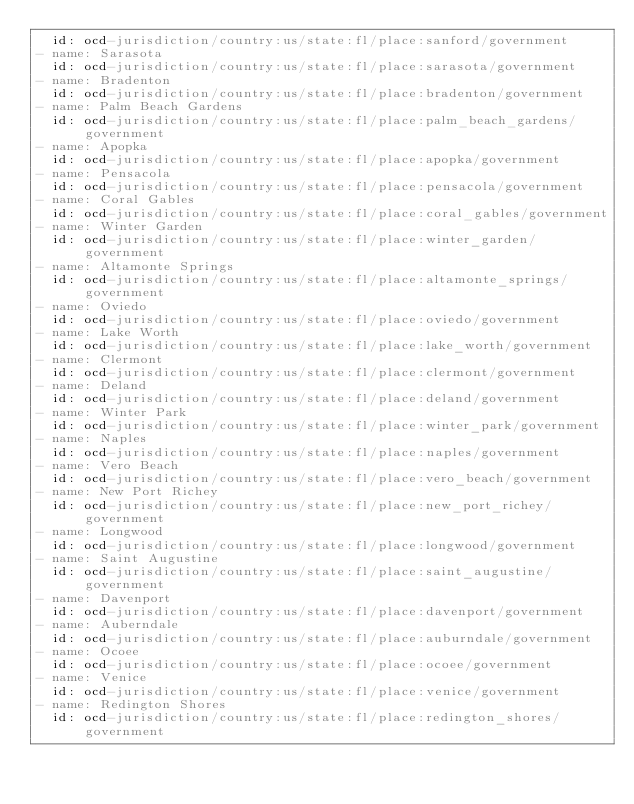<code> <loc_0><loc_0><loc_500><loc_500><_YAML_>  id: ocd-jurisdiction/country:us/state:fl/place:sanford/government
- name: Sarasota
  id: ocd-jurisdiction/country:us/state:fl/place:sarasota/government
- name: Bradenton
  id: ocd-jurisdiction/country:us/state:fl/place:bradenton/government
- name: Palm Beach Gardens
  id: ocd-jurisdiction/country:us/state:fl/place:palm_beach_gardens/government
- name: Apopka
  id: ocd-jurisdiction/country:us/state:fl/place:apopka/government
- name: Pensacola
  id: ocd-jurisdiction/country:us/state:fl/place:pensacola/government
- name: Coral Gables
  id: ocd-jurisdiction/country:us/state:fl/place:coral_gables/government
- name: Winter Garden
  id: ocd-jurisdiction/country:us/state:fl/place:winter_garden/government
- name: Altamonte Springs
  id: ocd-jurisdiction/country:us/state:fl/place:altamonte_springs/government
- name: Oviedo
  id: ocd-jurisdiction/country:us/state:fl/place:oviedo/government
- name: Lake Worth
  id: ocd-jurisdiction/country:us/state:fl/place:lake_worth/government
- name: Clermont
  id: ocd-jurisdiction/country:us/state:fl/place:clermont/government
- name: Deland
  id: ocd-jurisdiction/country:us/state:fl/place:deland/government
- name: Winter Park
  id: ocd-jurisdiction/country:us/state:fl/place:winter_park/government
- name: Naples
  id: ocd-jurisdiction/country:us/state:fl/place:naples/government
- name: Vero Beach
  id: ocd-jurisdiction/country:us/state:fl/place:vero_beach/government
- name: New Port Richey
  id: ocd-jurisdiction/country:us/state:fl/place:new_port_richey/government
- name: Longwood
  id: ocd-jurisdiction/country:us/state:fl/place:longwood/government
- name: Saint Augustine
  id: ocd-jurisdiction/country:us/state:fl/place:saint_augustine/government
- name: Davenport
  id: ocd-jurisdiction/country:us/state:fl/place:davenport/government
- name: Auberndale
  id: ocd-jurisdiction/country:us/state:fl/place:auburndale/government
- name: Ocoee
  id: ocd-jurisdiction/country:us/state:fl/place:ocoee/government
- name: Venice
  id: ocd-jurisdiction/country:us/state:fl/place:venice/government
- name: Redington Shores
  id: ocd-jurisdiction/country:us/state:fl/place:redington_shores/government
</code> 